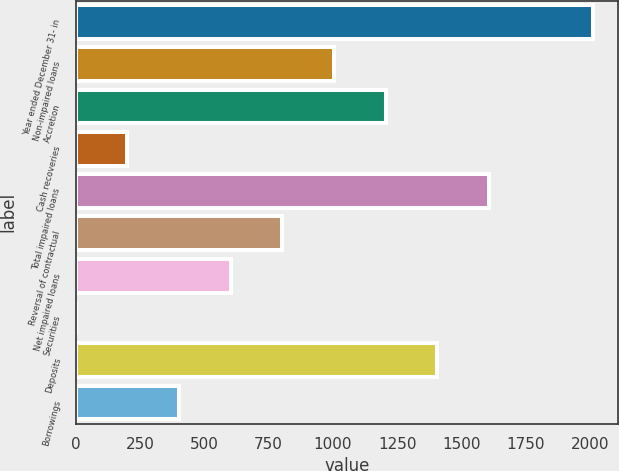Convert chart to OTSL. <chart><loc_0><loc_0><loc_500><loc_500><bar_chart><fcel>Year ended December 31- in<fcel>Non-impaired loans<fcel>Accretion<fcel>Cash recoveries<fcel>Total impaired loans<fcel>Reversal of contractual<fcel>Net impaired loans<fcel>Securities<fcel>Deposits<fcel>Borrowings<nl><fcel>2009<fcel>1004.55<fcel>1205.44<fcel>200.99<fcel>1607.22<fcel>803.66<fcel>602.77<fcel>0.1<fcel>1406.33<fcel>401.88<nl></chart> 